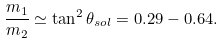Convert formula to latex. <formula><loc_0><loc_0><loc_500><loc_500>\frac { m _ { 1 } } { m _ { 2 } } \simeq \tan ^ { 2 } \theta _ { s o l } = 0 . 2 9 - 0 . 6 4 .</formula> 